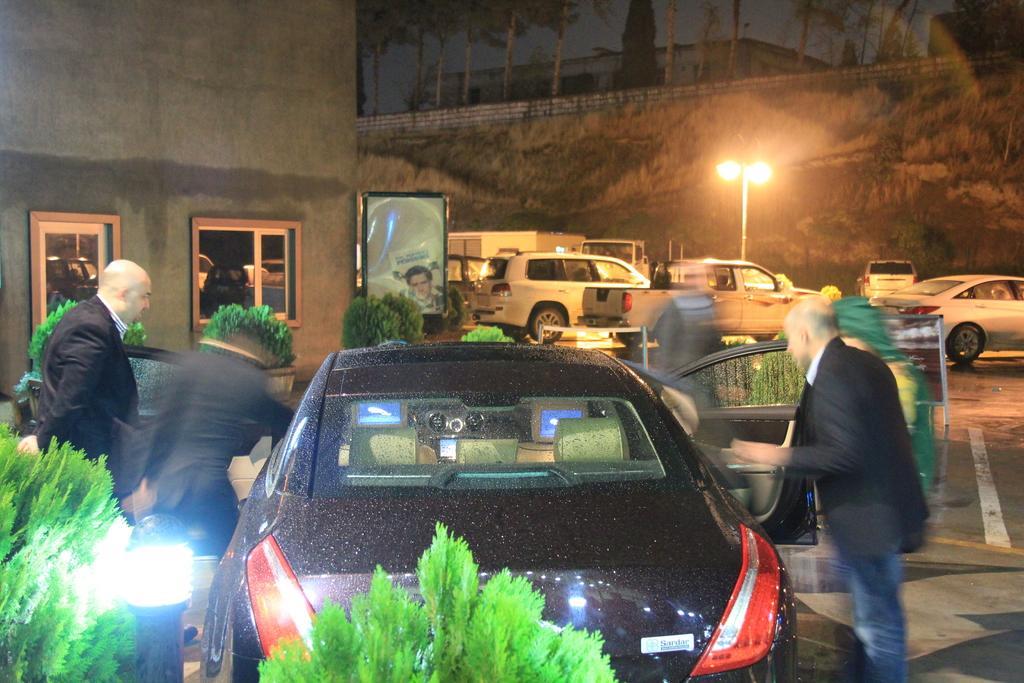In one or two sentences, can you explain what this image depicts? Background of the picture is dark. In the background we can see a building, trees and lights with a pole. We can see vehicles on the road. We can see people standing on either side of a black car. These are plants. 